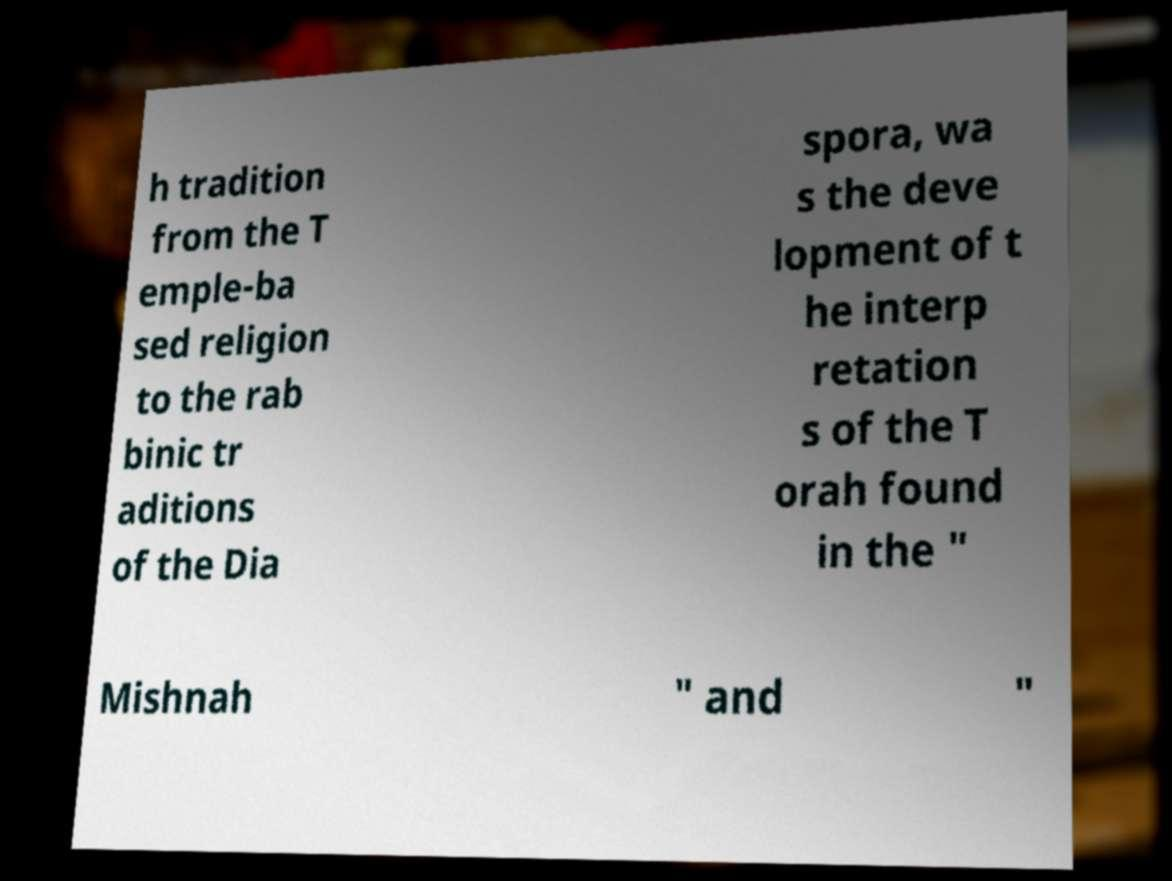Can you read and provide the text displayed in the image?This photo seems to have some interesting text. Can you extract and type it out for me? h tradition from the T emple-ba sed religion to the rab binic tr aditions of the Dia spora, wa s the deve lopment of t he interp retation s of the T orah found in the " Mishnah " and " 